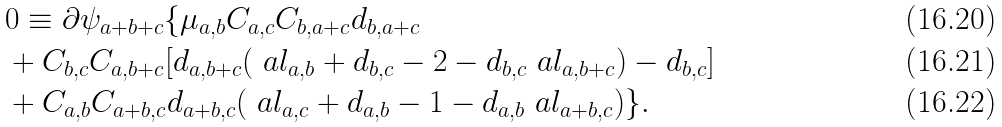<formula> <loc_0><loc_0><loc_500><loc_500>& 0 \equiv \partial \psi _ { a + b + c } \{ \mu _ { a , b } C _ { a , c } C _ { b , a + c } d _ { b , a + c } \\ & + C _ { b , c } C _ { a , b + c } [ d _ { a , b + c } ( \ a l _ { a , b } + d _ { b , c } - 2 - d _ { b , c } \ a l _ { a , b + c } ) - d _ { b , c } ] \\ & + C _ { a , b } C _ { a + b , c } d _ { a + b , c } ( \ a l _ { a , c } + d _ { a , b } - 1 - d _ { a , b } \ a l _ { a + b , c } ) \} .</formula> 